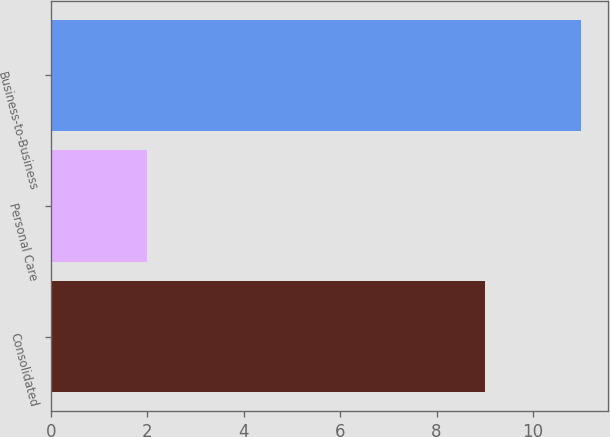<chart> <loc_0><loc_0><loc_500><loc_500><bar_chart><fcel>Consolidated<fcel>Personal Care<fcel>Business-to-Business<nl><fcel>9<fcel>2<fcel>11<nl></chart> 